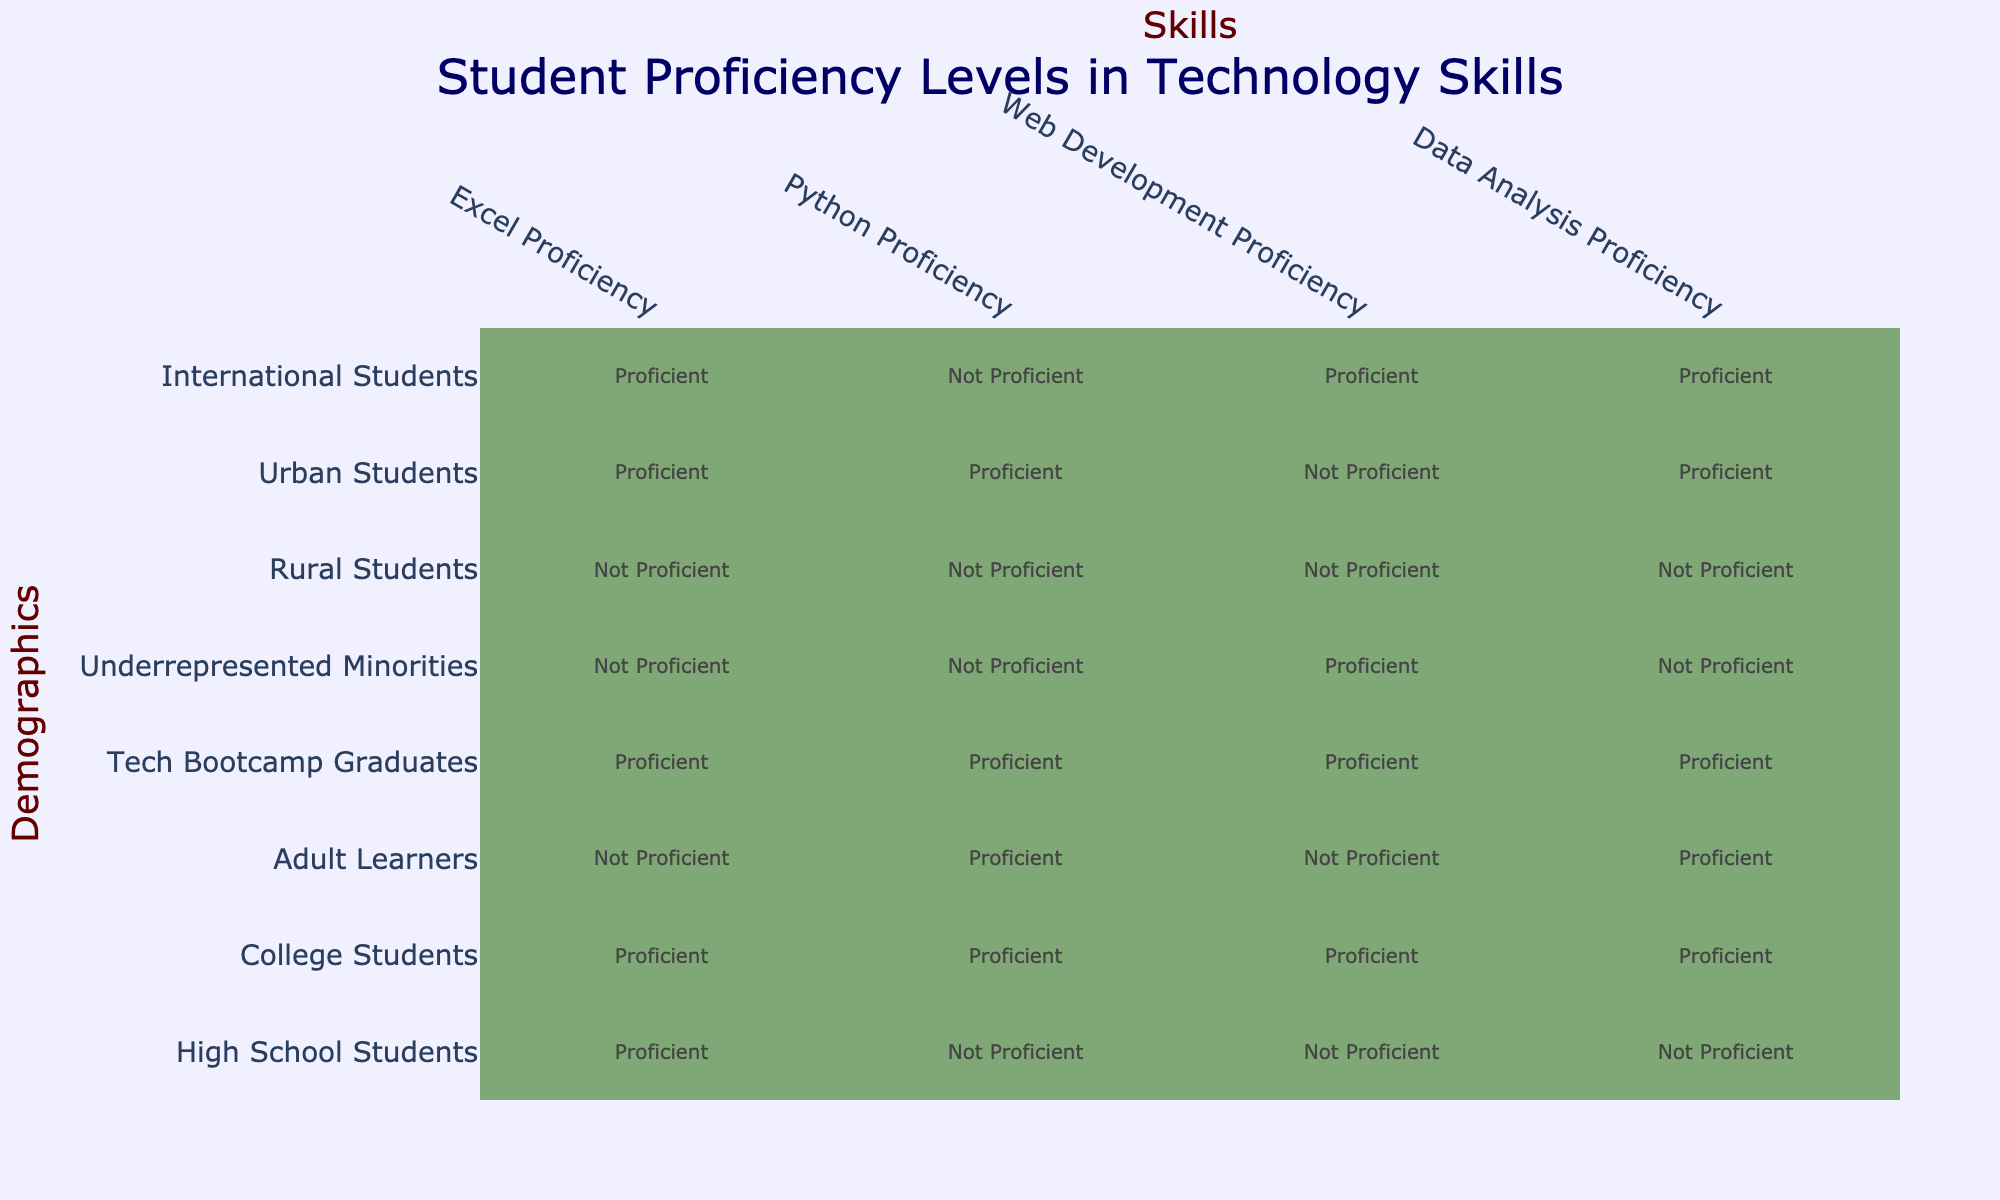What is the proficiency level in Excel for College Students? The table indicates that College Students have a proficiency level of "Proficient" in Excel.
Answer: Proficient How many demographics are proficient in Web Development? By examining the table, there are three demographics listed with "Proficient" in Web Development: College Students, Adult Learners, and Underrepresented Minorities. Therefore, the count is three.
Answer: 3 Do High School Students have proficiency in Data Analysis? The table clearly states that High School Students have a proficiency level of "Not Proficient" in Data Analysis.
Answer: No Which demographic group has the highest proficiency across all technology skills? Looking at the table, Tech Bootcamp Graduates are proficient in all skills: Excel, Python, Web Development, and Data Analysis. They are the only group with this level of proficiency across all categories.
Answer: Tech Bootcamp Graduates What is the difference in the number of proficient demographics between Python and Data Analysis? For Python, the proficient demographics are: College Students, Adult Learners, and Urban Students (3 total). For Data Analysis, the proficient demographics are: College Students and Adult Learners (2 total). The difference is calculated as 3 - 2 = 1.
Answer: 1 Are there any demographics that are not proficient in Excel? In the table, both Adult Learners and Underrepresented Minorities have a proficiency level of "Not Proficient" in Excel.
Answer: Yes Which demographic group has the most proficiency in Python? The table lists College Students, Adult Learners, and Tech Bootcamp Graduates as proficient in Python. Among these, College Students have the highest overall proficiency comparison with other skills, but if comparing only the skill of Python, each is proficient. So no single group is specified as "most."
Answer: College Students, Adult Learners, and Tech Bootcamp Graduates are all equally proficient What is the combined total number of Proficient levels for Rural Students and High School Students across all skills? For Rural Students, all skills show "Not Proficient," giving a count of 0. For High School Students, only Excel shows "Proficient," giving a count of 1. The total combined count is 0 + 1 = 1.
Answer: 1 